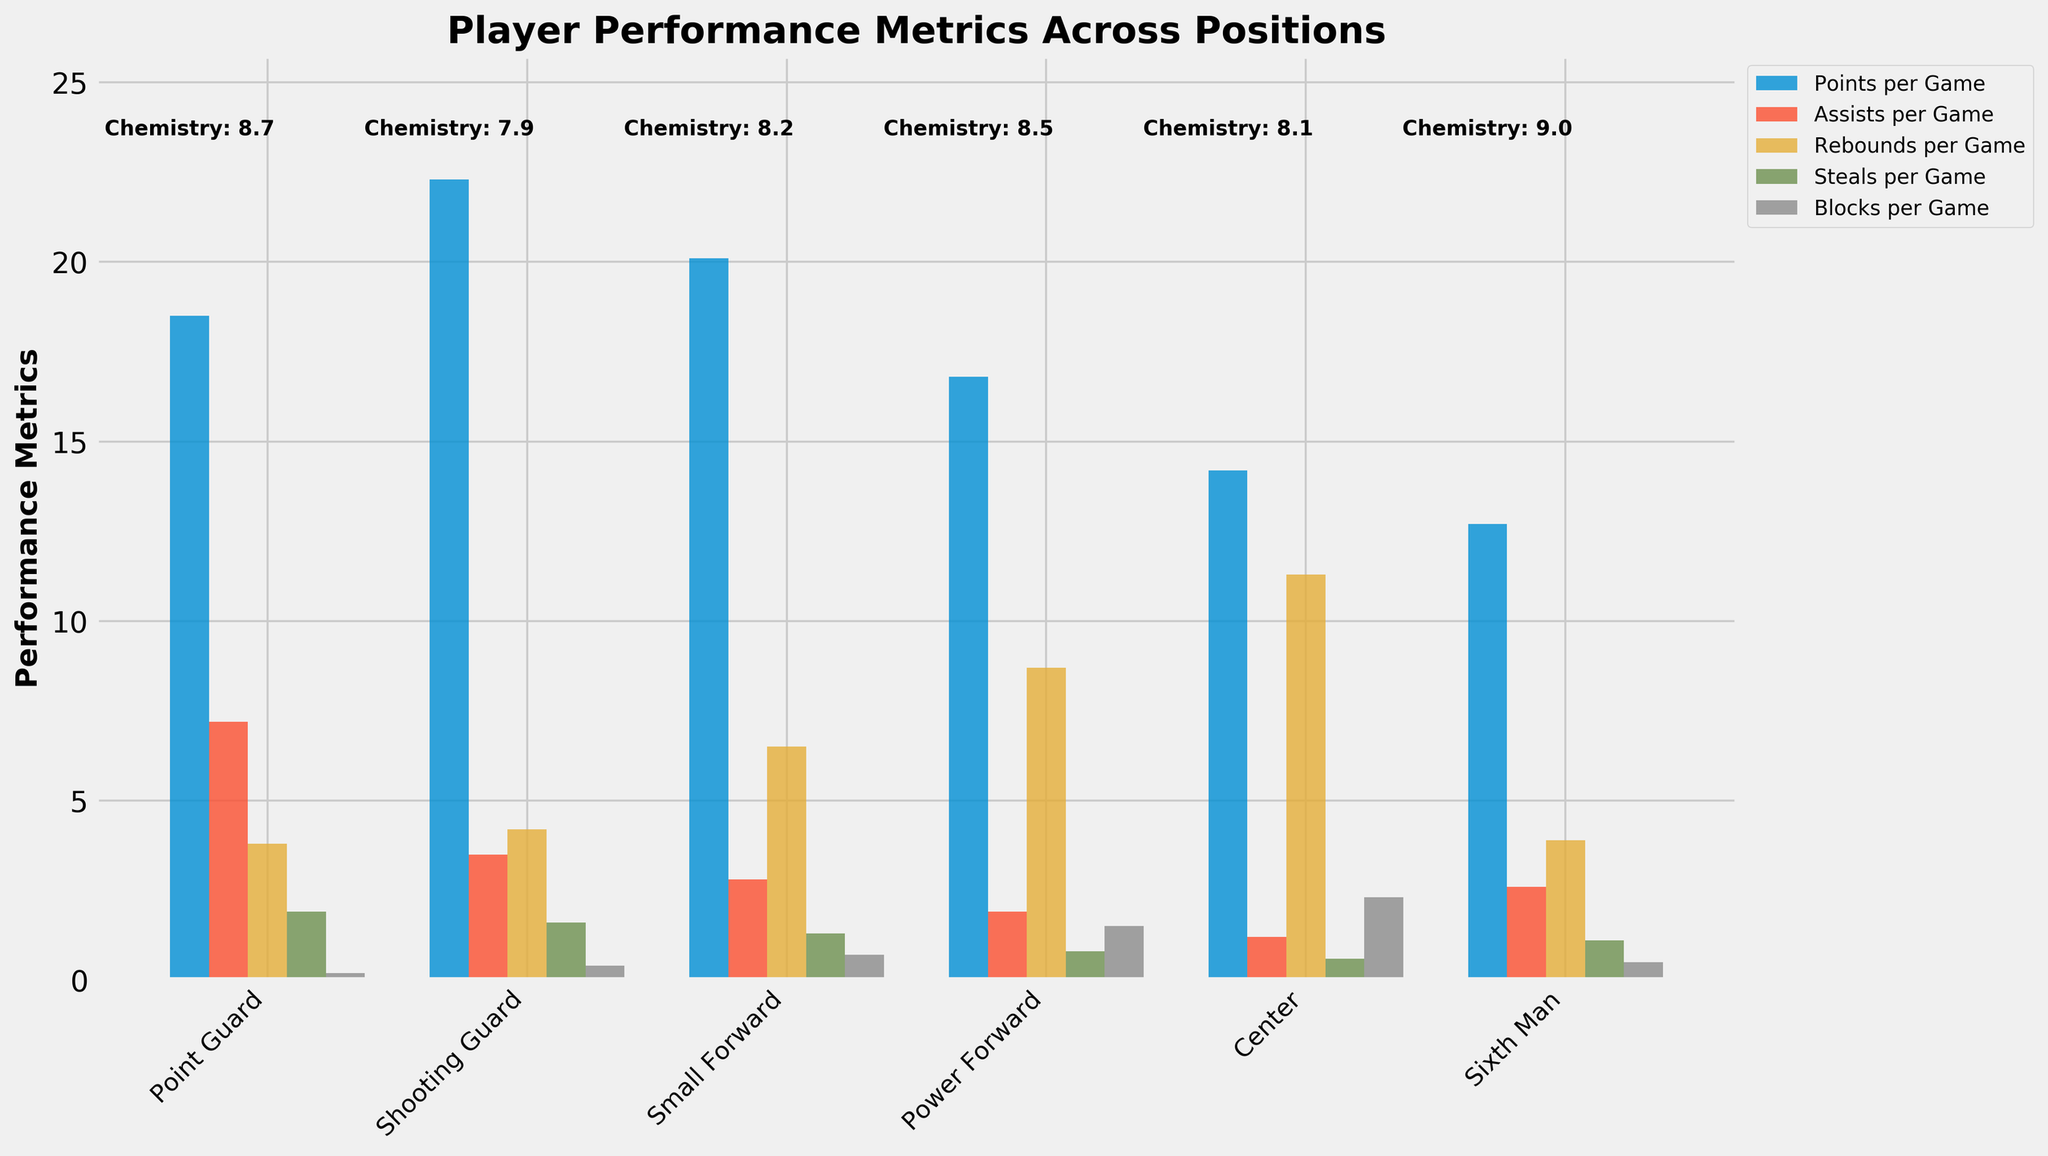What position has the highest points per game? To find the position with the highest points per game, examine the bars for each position under the "Points per Game" label. The Shooting Guard has the highest point at 22.3.
Answer: Shooting Guard Which position has the highest team chemistry score, and what is it? Look at the team chemistry scores listed above each bar cluster. The Sixth Man has the highest with a score of 9.0.
Answer: Sixth Man, 9.0 Comparing the Point Guard and Center, which position has more assists per game? Check the bars for the "Assists per Game" metric for both the Point Guard and Center positions. The Point Guard has 7.2 assists per game, whereas the Center has 1.2.
Answer: Point Guard What is the difference in rebounds per game between the Power Forward and the Small Forward? Find the rebound bars for both positions: Power Forward has 8.7, Small Forward has 6.5. The difference is 8.7 - 6.5 = 2.2.
Answer: 2.2 Which position has the lowest blocks per game, and what is the value? Locate the smallest bar in the "Blocks per Game" metric. The Point Guard has the lowest value at 0.2.
Answer: Point Guard, 0.2 What is the average points per game for the Point Guard, Shooting Guard, and Small Forward? Sum the points per game for these three positions and divide by 3: (18.5 + 22.3 + 20.1) / 3 = 60.9 / 3 = 20.3.
Answer: 20.3 Which two positions have the closest team chemistry scores, and what are these scores? Scan the team chemistry scores and find the closest pair. The Shooting Guard (7.9) and Center (8.1) have the closest scores with a difference of 0.2.
Answer: Shooting Guard, Center Between the Sixth Man and Power Forward, which position contributes more to steals per game, and by how much? Find the steals per game for both: Sixth Man has 1.1, and Power Forward has 0.8. The difference is 1.1 - 0.8 = 0.3.
Answer: Sixth Man, 0.3 